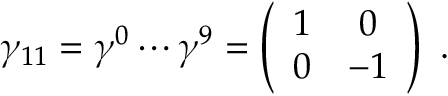Convert formula to latex. <formula><loc_0><loc_0><loc_500><loc_500>\gamma _ { 1 1 } = \gamma ^ { 0 } \cdots \gamma ^ { 9 } = \left ( \begin{array} { c c } { 1 } & { 0 } \\ { 0 } & { - 1 } \end{array} \right ) \ .</formula> 